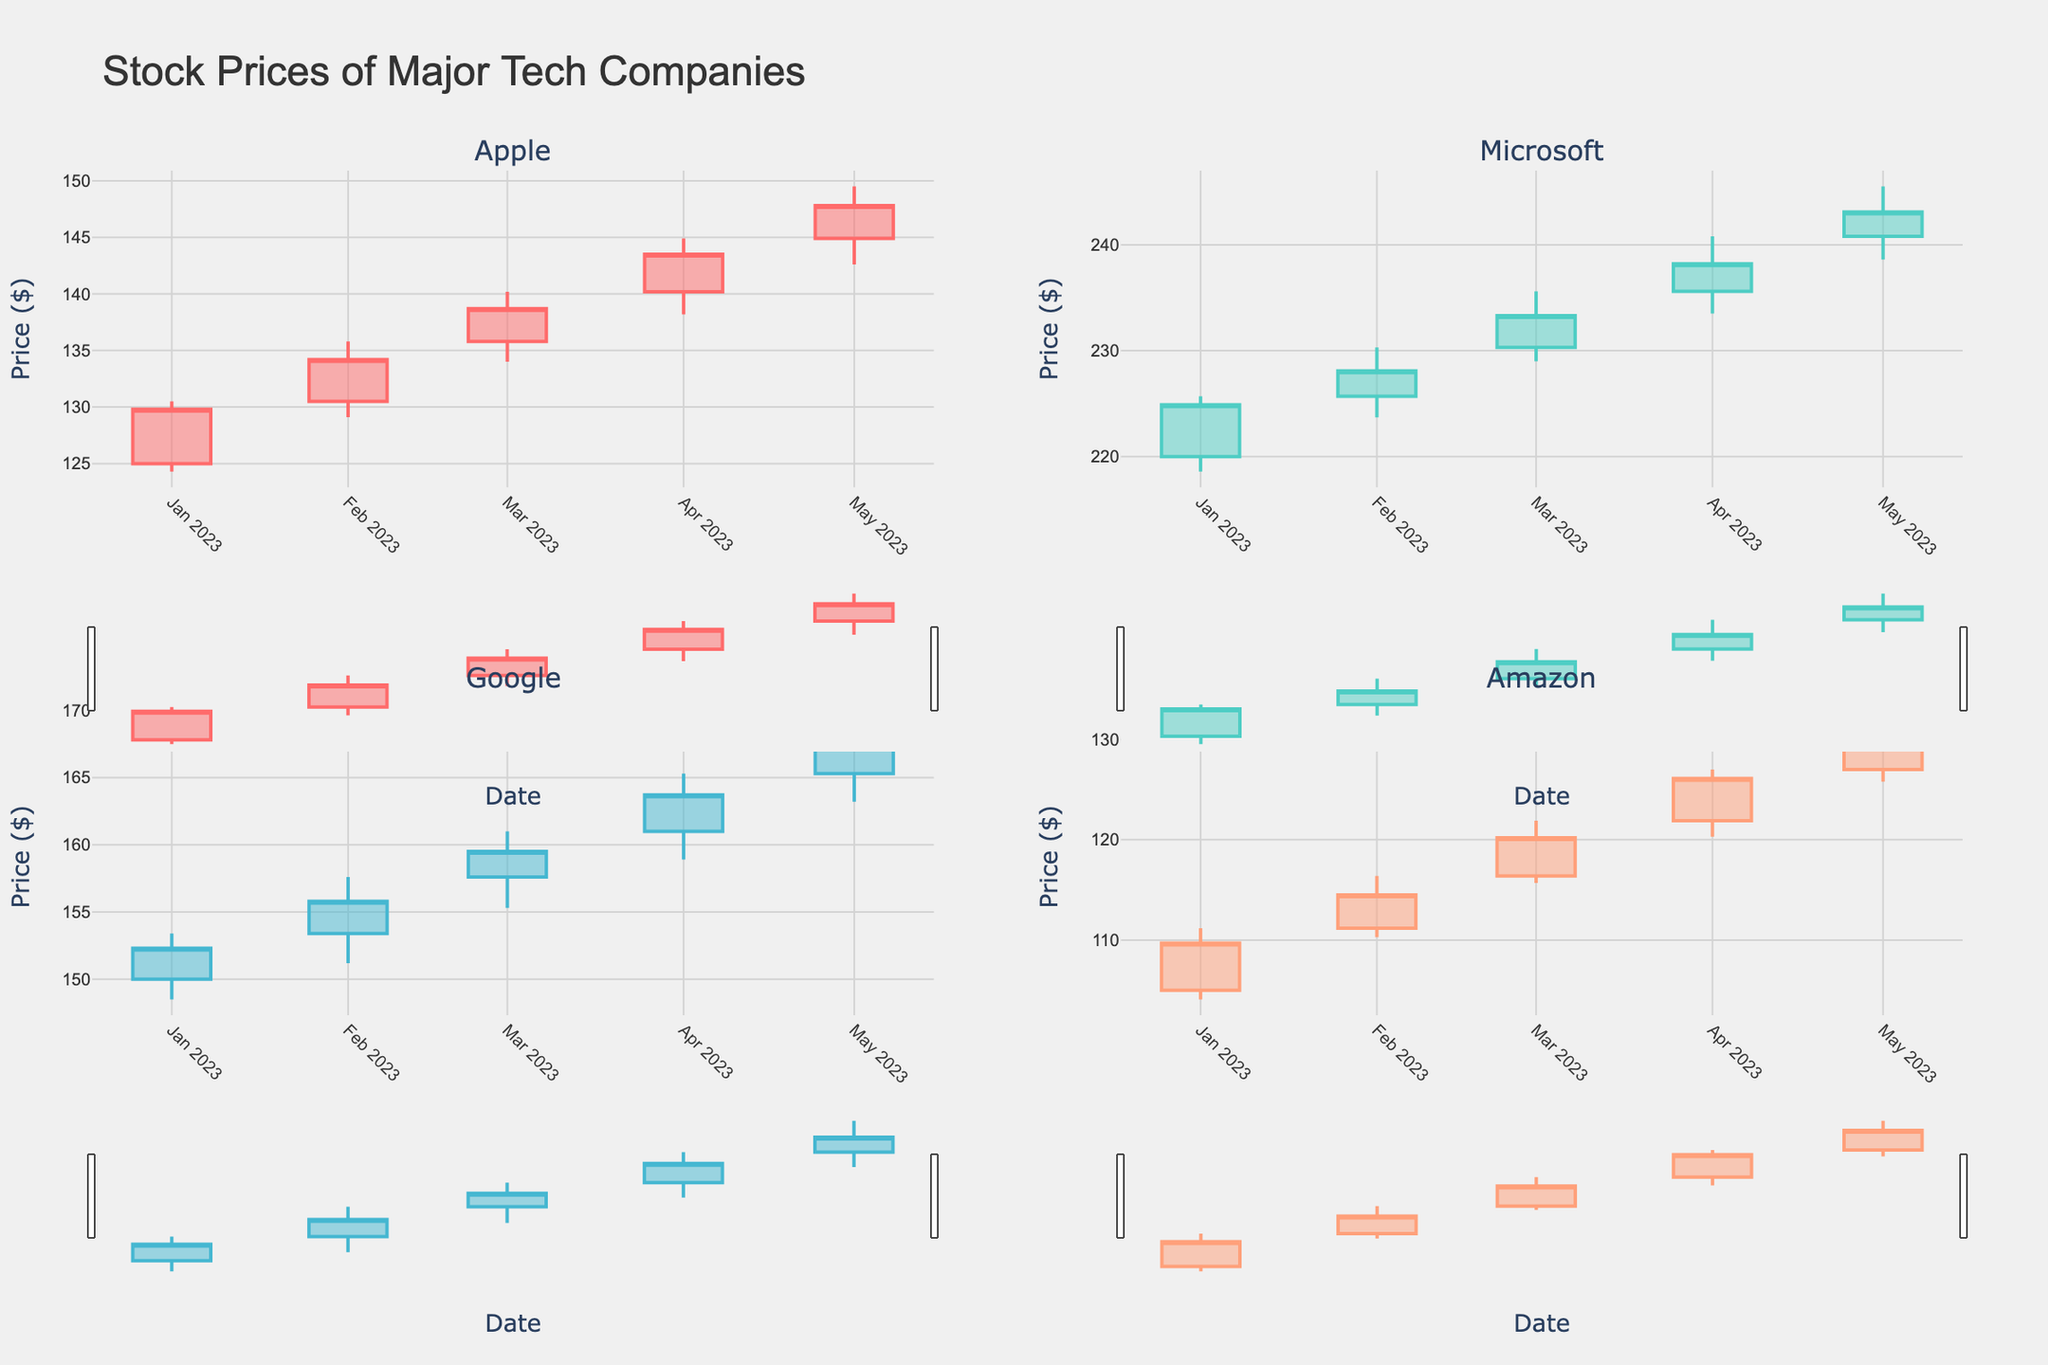What's the title of the figure? The title of the figure is the text displayed at the top of the plot. The title helps identify what the plot is about.
Answer: Stock Prices of Major Tech Companies How many companies are represented in the figure? The figure shows subplots for each company, and there are titles for four subplots representing different companies.
Answer: 4 What color represents the increasing line for Apple? The color used for the increasing line in the candlestick plot for Apple is specified in the code and can be visually identified in the plot.
Answer: #FF6B6B Which company had the highest closing price in May 2023? To find this, look at the closing prices in the May 2023 candlesticks for all companies and find the highest one.
Answer: Microsoft Between February and April 2023, did Apple's closing price ever decrease month-over-month? By comparing Apple's closing prices in February, March, and April, check if there's any month where the later closing price is lower than the previous month's. For clarification: Feb (134.2), Mar (138.7), Apr (143.5).
Answer: No What was the opening price of Microsoft in March 2023? Locate the candlestick for March 2023 in Microsoft's plot. The opening price is the bottom of the rectangular part of the candlestick if the price increased that month.
Answer: 230.3 Which company experienced the greatest volume of trade in January 2023? Review the trade volumes for each company in January 2023. The company with the highest numeric volume is the answer. Apple: 112500000, Microsoft: 85000000, Google: 78000000, Amazon: 92000000.
Answer: Apple Did Google's stock price ever close lower than it opened within any month? Investigate Google's monthly candlesticks. If any candlestick's closing price is below its opening price, Google’s stock price closed lower than it opened.
Answer: No Which company showed the most consistent increase in closing prices from January to May 2023? Look for a company that has a steady increase in closing prices every month from January to May 2023. All companies should have a continuous upward trend without any month showing a lower closing price than the previous one.
Answer: Google In which month did Amazon experience the largest range in stock price (difference between high and low)? For each month, subtract the low price from the high price for Amazon. Compare the results to find the month with the largest difference.
Answer: May 2023 